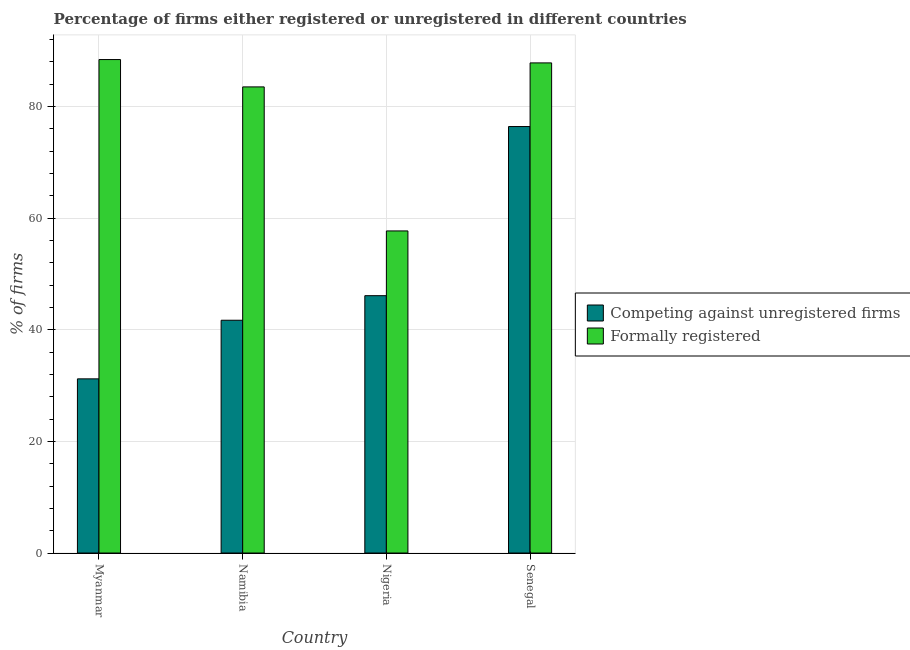Are the number of bars per tick equal to the number of legend labels?
Make the answer very short. Yes. How many bars are there on the 3rd tick from the left?
Your response must be concise. 2. What is the label of the 2nd group of bars from the left?
Make the answer very short. Namibia. In how many cases, is the number of bars for a given country not equal to the number of legend labels?
Give a very brief answer. 0. What is the percentage of formally registered firms in Nigeria?
Provide a succinct answer. 57.7. Across all countries, what is the maximum percentage of registered firms?
Offer a very short reply. 76.4. Across all countries, what is the minimum percentage of formally registered firms?
Provide a short and direct response. 57.7. In which country was the percentage of registered firms maximum?
Your answer should be compact. Senegal. In which country was the percentage of formally registered firms minimum?
Ensure brevity in your answer.  Nigeria. What is the total percentage of registered firms in the graph?
Make the answer very short. 195.4. What is the difference between the percentage of formally registered firms in Nigeria and that in Senegal?
Offer a terse response. -30.1. What is the difference between the percentage of registered firms in Namibia and the percentage of formally registered firms in Nigeria?
Make the answer very short. -16. What is the average percentage of registered firms per country?
Keep it short and to the point. 48.85. What is the difference between the percentage of formally registered firms and percentage of registered firms in Senegal?
Ensure brevity in your answer.  11.4. In how many countries, is the percentage of registered firms greater than 76 %?
Ensure brevity in your answer.  1. What is the ratio of the percentage of formally registered firms in Namibia to that in Nigeria?
Keep it short and to the point. 1.45. What is the difference between the highest and the second highest percentage of formally registered firms?
Your response must be concise. 0.6. What is the difference between the highest and the lowest percentage of formally registered firms?
Your answer should be compact. 30.7. In how many countries, is the percentage of formally registered firms greater than the average percentage of formally registered firms taken over all countries?
Ensure brevity in your answer.  3. Is the sum of the percentage of formally registered firms in Myanmar and Senegal greater than the maximum percentage of registered firms across all countries?
Offer a terse response. Yes. What does the 2nd bar from the left in Nigeria represents?
Your answer should be very brief. Formally registered. What does the 2nd bar from the right in Senegal represents?
Provide a short and direct response. Competing against unregistered firms. How many bars are there?
Ensure brevity in your answer.  8. How many countries are there in the graph?
Give a very brief answer. 4. What is the difference between two consecutive major ticks on the Y-axis?
Keep it short and to the point. 20. Does the graph contain any zero values?
Make the answer very short. No. Does the graph contain grids?
Make the answer very short. Yes. What is the title of the graph?
Keep it short and to the point. Percentage of firms either registered or unregistered in different countries. Does "Age 65(female)" appear as one of the legend labels in the graph?
Your answer should be very brief. No. What is the label or title of the Y-axis?
Provide a short and direct response. % of firms. What is the % of firms in Competing against unregistered firms in Myanmar?
Keep it short and to the point. 31.2. What is the % of firms in Formally registered in Myanmar?
Ensure brevity in your answer.  88.4. What is the % of firms in Competing against unregistered firms in Namibia?
Your answer should be compact. 41.7. What is the % of firms of Formally registered in Namibia?
Make the answer very short. 83.5. What is the % of firms in Competing against unregistered firms in Nigeria?
Offer a very short reply. 46.1. What is the % of firms of Formally registered in Nigeria?
Your answer should be compact. 57.7. What is the % of firms in Competing against unregistered firms in Senegal?
Offer a very short reply. 76.4. What is the % of firms of Formally registered in Senegal?
Your answer should be compact. 87.8. Across all countries, what is the maximum % of firms in Competing against unregistered firms?
Make the answer very short. 76.4. Across all countries, what is the maximum % of firms of Formally registered?
Provide a succinct answer. 88.4. Across all countries, what is the minimum % of firms of Competing against unregistered firms?
Your response must be concise. 31.2. Across all countries, what is the minimum % of firms in Formally registered?
Keep it short and to the point. 57.7. What is the total % of firms of Competing against unregistered firms in the graph?
Make the answer very short. 195.4. What is the total % of firms in Formally registered in the graph?
Your answer should be very brief. 317.4. What is the difference between the % of firms of Formally registered in Myanmar and that in Namibia?
Make the answer very short. 4.9. What is the difference between the % of firms in Competing against unregistered firms in Myanmar and that in Nigeria?
Ensure brevity in your answer.  -14.9. What is the difference between the % of firms of Formally registered in Myanmar and that in Nigeria?
Provide a succinct answer. 30.7. What is the difference between the % of firms in Competing against unregistered firms in Myanmar and that in Senegal?
Provide a succinct answer. -45.2. What is the difference between the % of firms in Formally registered in Myanmar and that in Senegal?
Keep it short and to the point. 0.6. What is the difference between the % of firms in Formally registered in Namibia and that in Nigeria?
Ensure brevity in your answer.  25.8. What is the difference between the % of firms of Competing against unregistered firms in Namibia and that in Senegal?
Keep it short and to the point. -34.7. What is the difference between the % of firms in Competing against unregistered firms in Nigeria and that in Senegal?
Offer a terse response. -30.3. What is the difference between the % of firms in Formally registered in Nigeria and that in Senegal?
Provide a short and direct response. -30.1. What is the difference between the % of firms of Competing against unregistered firms in Myanmar and the % of firms of Formally registered in Namibia?
Offer a very short reply. -52.3. What is the difference between the % of firms of Competing against unregistered firms in Myanmar and the % of firms of Formally registered in Nigeria?
Your answer should be compact. -26.5. What is the difference between the % of firms in Competing against unregistered firms in Myanmar and the % of firms in Formally registered in Senegal?
Give a very brief answer. -56.6. What is the difference between the % of firms in Competing against unregistered firms in Namibia and the % of firms in Formally registered in Senegal?
Provide a succinct answer. -46.1. What is the difference between the % of firms of Competing against unregistered firms in Nigeria and the % of firms of Formally registered in Senegal?
Keep it short and to the point. -41.7. What is the average % of firms of Competing against unregistered firms per country?
Your answer should be very brief. 48.85. What is the average % of firms in Formally registered per country?
Give a very brief answer. 79.35. What is the difference between the % of firms of Competing against unregistered firms and % of firms of Formally registered in Myanmar?
Offer a terse response. -57.2. What is the difference between the % of firms of Competing against unregistered firms and % of firms of Formally registered in Namibia?
Provide a short and direct response. -41.8. What is the difference between the % of firms of Competing against unregistered firms and % of firms of Formally registered in Senegal?
Ensure brevity in your answer.  -11.4. What is the ratio of the % of firms of Competing against unregistered firms in Myanmar to that in Namibia?
Give a very brief answer. 0.75. What is the ratio of the % of firms of Formally registered in Myanmar to that in Namibia?
Offer a very short reply. 1.06. What is the ratio of the % of firms of Competing against unregistered firms in Myanmar to that in Nigeria?
Provide a short and direct response. 0.68. What is the ratio of the % of firms of Formally registered in Myanmar to that in Nigeria?
Make the answer very short. 1.53. What is the ratio of the % of firms in Competing against unregistered firms in Myanmar to that in Senegal?
Provide a succinct answer. 0.41. What is the ratio of the % of firms in Formally registered in Myanmar to that in Senegal?
Your answer should be compact. 1.01. What is the ratio of the % of firms of Competing against unregistered firms in Namibia to that in Nigeria?
Ensure brevity in your answer.  0.9. What is the ratio of the % of firms of Formally registered in Namibia to that in Nigeria?
Offer a very short reply. 1.45. What is the ratio of the % of firms of Competing against unregistered firms in Namibia to that in Senegal?
Give a very brief answer. 0.55. What is the ratio of the % of firms in Formally registered in Namibia to that in Senegal?
Your answer should be very brief. 0.95. What is the ratio of the % of firms in Competing against unregistered firms in Nigeria to that in Senegal?
Provide a short and direct response. 0.6. What is the ratio of the % of firms in Formally registered in Nigeria to that in Senegal?
Your response must be concise. 0.66. What is the difference between the highest and the second highest % of firms in Competing against unregistered firms?
Your response must be concise. 30.3. What is the difference between the highest and the second highest % of firms of Formally registered?
Your answer should be very brief. 0.6. What is the difference between the highest and the lowest % of firms in Competing against unregistered firms?
Provide a succinct answer. 45.2. What is the difference between the highest and the lowest % of firms of Formally registered?
Ensure brevity in your answer.  30.7. 